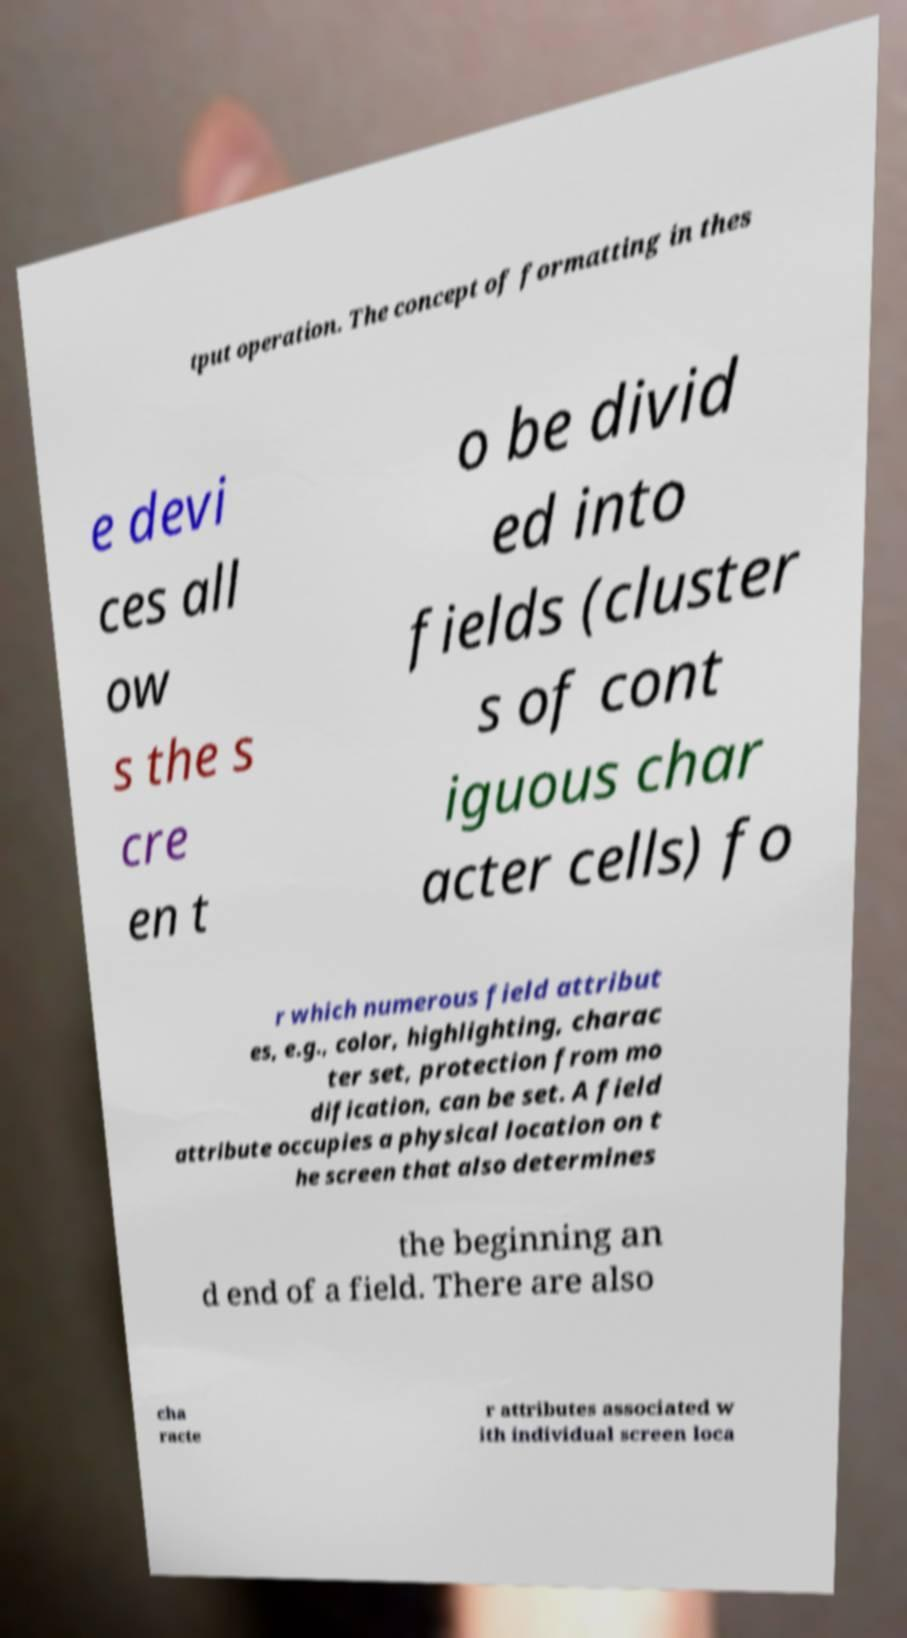Can you accurately transcribe the text from the provided image for me? tput operation. The concept of formatting in thes e devi ces all ow s the s cre en t o be divid ed into fields (cluster s of cont iguous char acter cells) fo r which numerous field attribut es, e.g., color, highlighting, charac ter set, protection from mo dification, can be set. A field attribute occupies a physical location on t he screen that also determines the beginning an d end of a field. There are also cha racte r attributes associated w ith individual screen loca 